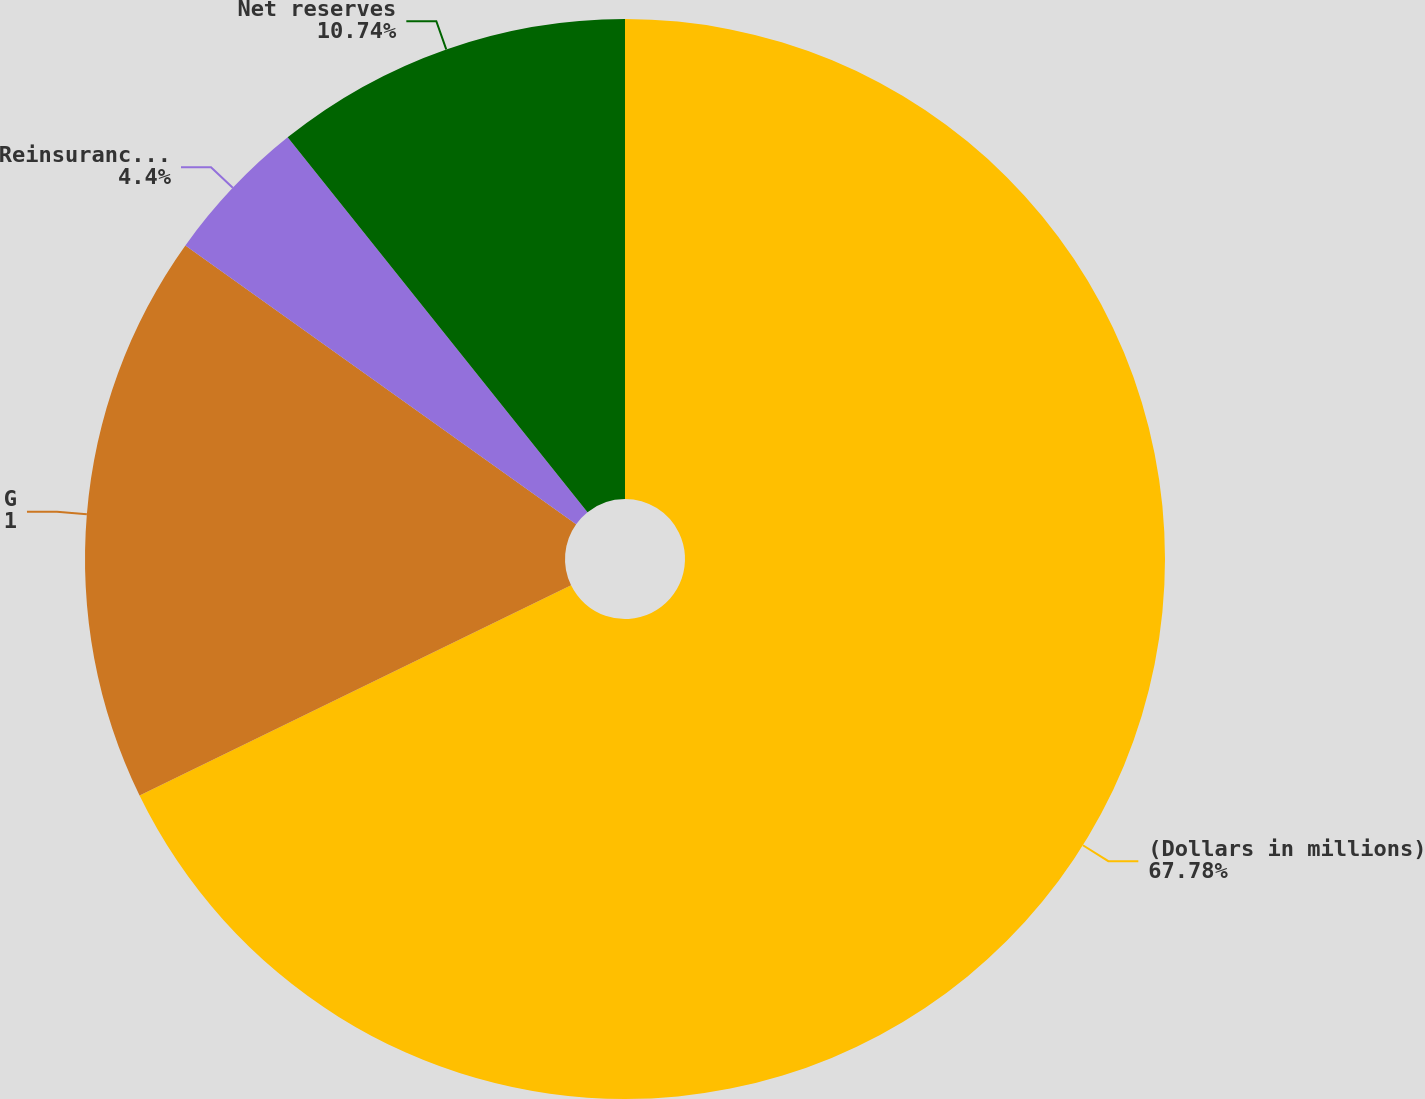<chart> <loc_0><loc_0><loc_500><loc_500><pie_chart><fcel>(Dollars in millions)<fcel>Gross reserves<fcel>Reinsurance receivable<fcel>Net reserves<nl><fcel>67.79%<fcel>17.08%<fcel>4.4%<fcel>10.74%<nl></chart> 